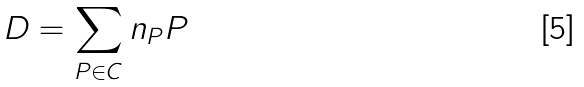<formula> <loc_0><loc_0><loc_500><loc_500>D = \sum _ { P \in C } n _ { P } P</formula> 